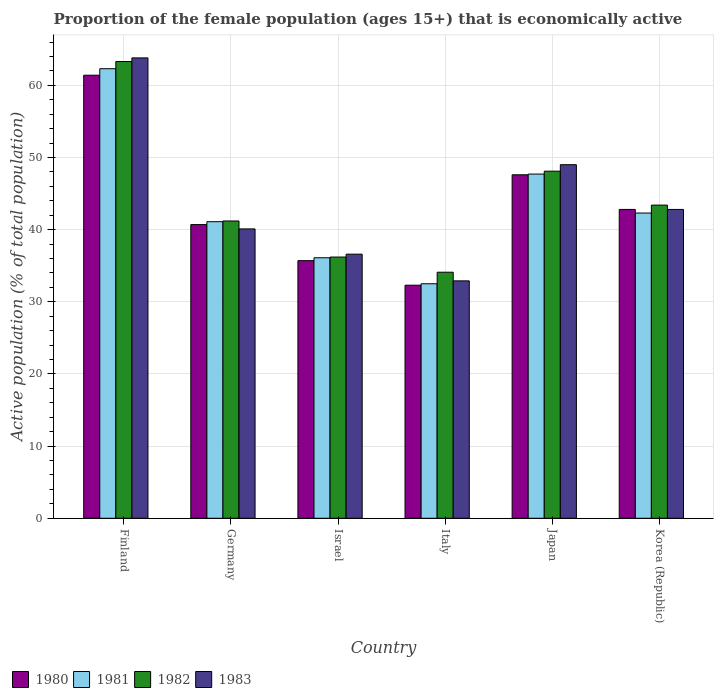Are the number of bars on each tick of the X-axis equal?
Offer a very short reply. Yes. How many bars are there on the 5th tick from the left?
Offer a very short reply. 4. What is the proportion of the female population that is economically active in 1981 in Korea (Republic)?
Keep it short and to the point. 42.3. Across all countries, what is the maximum proportion of the female population that is economically active in 1982?
Offer a terse response. 63.3. Across all countries, what is the minimum proportion of the female population that is economically active in 1983?
Your answer should be very brief. 32.9. In which country was the proportion of the female population that is economically active in 1982 minimum?
Offer a terse response. Italy. What is the total proportion of the female population that is economically active in 1982 in the graph?
Offer a very short reply. 266.3. What is the difference between the proportion of the female population that is economically active in 1980 in Finland and that in Italy?
Provide a succinct answer. 29.1. What is the difference between the proportion of the female population that is economically active in 1980 in Israel and the proportion of the female population that is economically active in 1981 in Finland?
Keep it short and to the point. -26.6. What is the average proportion of the female population that is economically active in 1981 per country?
Offer a terse response. 43.67. What is the difference between the proportion of the female population that is economically active of/in 1980 and proportion of the female population that is economically active of/in 1982 in Italy?
Offer a terse response. -1.8. What is the ratio of the proportion of the female population that is economically active in 1982 in Israel to that in Italy?
Give a very brief answer. 1.06. Is the difference between the proportion of the female population that is economically active in 1980 in Finland and Germany greater than the difference between the proportion of the female population that is economically active in 1982 in Finland and Germany?
Keep it short and to the point. No. What is the difference between the highest and the lowest proportion of the female population that is economically active in 1983?
Provide a succinct answer. 30.9. Is the sum of the proportion of the female population that is economically active in 1980 in Israel and Italy greater than the maximum proportion of the female population that is economically active in 1981 across all countries?
Provide a succinct answer. Yes. Is it the case that in every country, the sum of the proportion of the female population that is economically active in 1982 and proportion of the female population that is economically active in 1981 is greater than the sum of proportion of the female population that is economically active in 1983 and proportion of the female population that is economically active in 1980?
Your response must be concise. No. What does the 2nd bar from the left in Israel represents?
Your answer should be very brief. 1981. How many bars are there?
Your answer should be very brief. 24. Are all the bars in the graph horizontal?
Give a very brief answer. No. How many countries are there in the graph?
Provide a short and direct response. 6. What is the difference between two consecutive major ticks on the Y-axis?
Keep it short and to the point. 10. Does the graph contain any zero values?
Ensure brevity in your answer.  No. Where does the legend appear in the graph?
Your answer should be compact. Bottom left. What is the title of the graph?
Your answer should be compact. Proportion of the female population (ages 15+) that is economically active. What is the label or title of the X-axis?
Offer a very short reply. Country. What is the label or title of the Y-axis?
Ensure brevity in your answer.  Active population (% of total population). What is the Active population (% of total population) of 1980 in Finland?
Ensure brevity in your answer.  61.4. What is the Active population (% of total population) of 1981 in Finland?
Ensure brevity in your answer.  62.3. What is the Active population (% of total population) of 1982 in Finland?
Your answer should be compact. 63.3. What is the Active population (% of total population) of 1983 in Finland?
Give a very brief answer. 63.8. What is the Active population (% of total population) of 1980 in Germany?
Your response must be concise. 40.7. What is the Active population (% of total population) in 1981 in Germany?
Make the answer very short. 41.1. What is the Active population (% of total population) of 1982 in Germany?
Make the answer very short. 41.2. What is the Active population (% of total population) in 1983 in Germany?
Offer a terse response. 40.1. What is the Active population (% of total population) in 1980 in Israel?
Provide a succinct answer. 35.7. What is the Active population (% of total population) in 1981 in Israel?
Ensure brevity in your answer.  36.1. What is the Active population (% of total population) in 1982 in Israel?
Provide a succinct answer. 36.2. What is the Active population (% of total population) in 1983 in Israel?
Provide a short and direct response. 36.6. What is the Active population (% of total population) in 1980 in Italy?
Make the answer very short. 32.3. What is the Active population (% of total population) of 1981 in Italy?
Your answer should be compact. 32.5. What is the Active population (% of total population) of 1982 in Italy?
Ensure brevity in your answer.  34.1. What is the Active population (% of total population) of 1983 in Italy?
Keep it short and to the point. 32.9. What is the Active population (% of total population) of 1980 in Japan?
Your response must be concise. 47.6. What is the Active population (% of total population) of 1981 in Japan?
Provide a short and direct response. 47.7. What is the Active population (% of total population) in 1982 in Japan?
Offer a terse response. 48.1. What is the Active population (% of total population) in 1983 in Japan?
Keep it short and to the point. 49. What is the Active population (% of total population) of 1980 in Korea (Republic)?
Give a very brief answer. 42.8. What is the Active population (% of total population) of 1981 in Korea (Republic)?
Provide a short and direct response. 42.3. What is the Active population (% of total population) of 1982 in Korea (Republic)?
Your answer should be very brief. 43.4. What is the Active population (% of total population) in 1983 in Korea (Republic)?
Give a very brief answer. 42.8. Across all countries, what is the maximum Active population (% of total population) of 1980?
Provide a succinct answer. 61.4. Across all countries, what is the maximum Active population (% of total population) of 1981?
Make the answer very short. 62.3. Across all countries, what is the maximum Active population (% of total population) in 1982?
Your answer should be very brief. 63.3. Across all countries, what is the maximum Active population (% of total population) in 1983?
Offer a very short reply. 63.8. Across all countries, what is the minimum Active population (% of total population) of 1980?
Your answer should be compact. 32.3. Across all countries, what is the minimum Active population (% of total population) in 1981?
Your answer should be compact. 32.5. Across all countries, what is the minimum Active population (% of total population) in 1982?
Your answer should be compact. 34.1. Across all countries, what is the minimum Active population (% of total population) in 1983?
Provide a short and direct response. 32.9. What is the total Active population (% of total population) of 1980 in the graph?
Keep it short and to the point. 260.5. What is the total Active population (% of total population) of 1981 in the graph?
Your response must be concise. 262. What is the total Active population (% of total population) of 1982 in the graph?
Offer a very short reply. 266.3. What is the total Active population (% of total population) of 1983 in the graph?
Give a very brief answer. 265.2. What is the difference between the Active population (% of total population) in 1980 in Finland and that in Germany?
Offer a terse response. 20.7. What is the difference between the Active population (% of total population) in 1981 in Finland and that in Germany?
Offer a terse response. 21.2. What is the difference between the Active population (% of total population) of 1982 in Finland and that in Germany?
Your answer should be very brief. 22.1. What is the difference between the Active population (% of total population) in 1983 in Finland and that in Germany?
Offer a very short reply. 23.7. What is the difference between the Active population (% of total population) in 1980 in Finland and that in Israel?
Make the answer very short. 25.7. What is the difference between the Active population (% of total population) in 1981 in Finland and that in Israel?
Your answer should be compact. 26.2. What is the difference between the Active population (% of total population) in 1982 in Finland and that in Israel?
Make the answer very short. 27.1. What is the difference between the Active population (% of total population) of 1983 in Finland and that in Israel?
Your answer should be compact. 27.2. What is the difference between the Active population (% of total population) of 1980 in Finland and that in Italy?
Give a very brief answer. 29.1. What is the difference between the Active population (% of total population) of 1981 in Finland and that in Italy?
Ensure brevity in your answer.  29.8. What is the difference between the Active population (% of total population) of 1982 in Finland and that in Italy?
Ensure brevity in your answer.  29.2. What is the difference between the Active population (% of total population) in 1983 in Finland and that in Italy?
Keep it short and to the point. 30.9. What is the difference between the Active population (% of total population) of 1982 in Finland and that in Japan?
Your answer should be compact. 15.2. What is the difference between the Active population (% of total population) in 1983 in Finland and that in Japan?
Keep it short and to the point. 14.8. What is the difference between the Active population (% of total population) of 1980 in Finland and that in Korea (Republic)?
Give a very brief answer. 18.6. What is the difference between the Active population (% of total population) in 1982 in Germany and that in Italy?
Your answer should be compact. 7.1. What is the difference between the Active population (% of total population) in 1983 in Germany and that in Italy?
Your response must be concise. 7.2. What is the difference between the Active population (% of total population) in 1980 in Germany and that in Japan?
Your answer should be very brief. -6.9. What is the difference between the Active population (% of total population) in 1981 in Germany and that in Japan?
Keep it short and to the point. -6.6. What is the difference between the Active population (% of total population) of 1980 in Germany and that in Korea (Republic)?
Offer a very short reply. -2.1. What is the difference between the Active population (% of total population) in 1982 in Germany and that in Korea (Republic)?
Provide a succinct answer. -2.2. What is the difference between the Active population (% of total population) of 1983 in Germany and that in Korea (Republic)?
Give a very brief answer. -2.7. What is the difference between the Active population (% of total population) of 1980 in Israel and that in Italy?
Make the answer very short. 3.4. What is the difference between the Active population (% of total population) in 1981 in Israel and that in Italy?
Your response must be concise. 3.6. What is the difference between the Active population (% of total population) of 1981 in Israel and that in Japan?
Provide a short and direct response. -11.6. What is the difference between the Active population (% of total population) in 1983 in Israel and that in Japan?
Keep it short and to the point. -12.4. What is the difference between the Active population (% of total population) in 1980 in Italy and that in Japan?
Offer a terse response. -15.3. What is the difference between the Active population (% of total population) of 1981 in Italy and that in Japan?
Your answer should be very brief. -15.2. What is the difference between the Active population (% of total population) of 1982 in Italy and that in Japan?
Offer a terse response. -14. What is the difference between the Active population (% of total population) in 1983 in Italy and that in Japan?
Make the answer very short. -16.1. What is the difference between the Active population (% of total population) of 1983 in Italy and that in Korea (Republic)?
Your answer should be compact. -9.9. What is the difference between the Active population (% of total population) of 1980 in Japan and that in Korea (Republic)?
Make the answer very short. 4.8. What is the difference between the Active population (% of total population) in 1981 in Japan and that in Korea (Republic)?
Provide a short and direct response. 5.4. What is the difference between the Active population (% of total population) of 1980 in Finland and the Active population (% of total population) of 1981 in Germany?
Provide a short and direct response. 20.3. What is the difference between the Active population (% of total population) of 1980 in Finland and the Active population (% of total population) of 1982 in Germany?
Your answer should be very brief. 20.2. What is the difference between the Active population (% of total population) of 1980 in Finland and the Active population (% of total population) of 1983 in Germany?
Keep it short and to the point. 21.3. What is the difference between the Active population (% of total population) in 1981 in Finland and the Active population (% of total population) in 1982 in Germany?
Provide a short and direct response. 21.1. What is the difference between the Active population (% of total population) of 1981 in Finland and the Active population (% of total population) of 1983 in Germany?
Your answer should be compact. 22.2. What is the difference between the Active population (% of total population) of 1982 in Finland and the Active population (% of total population) of 1983 in Germany?
Your response must be concise. 23.2. What is the difference between the Active population (% of total population) in 1980 in Finland and the Active population (% of total population) in 1981 in Israel?
Ensure brevity in your answer.  25.3. What is the difference between the Active population (% of total population) of 1980 in Finland and the Active population (% of total population) of 1982 in Israel?
Ensure brevity in your answer.  25.2. What is the difference between the Active population (% of total population) of 1980 in Finland and the Active population (% of total population) of 1983 in Israel?
Keep it short and to the point. 24.8. What is the difference between the Active population (% of total population) in 1981 in Finland and the Active population (% of total population) in 1982 in Israel?
Make the answer very short. 26.1. What is the difference between the Active population (% of total population) of 1981 in Finland and the Active population (% of total population) of 1983 in Israel?
Give a very brief answer. 25.7. What is the difference between the Active population (% of total population) in 1982 in Finland and the Active population (% of total population) in 1983 in Israel?
Provide a succinct answer. 26.7. What is the difference between the Active population (% of total population) in 1980 in Finland and the Active population (% of total population) in 1981 in Italy?
Make the answer very short. 28.9. What is the difference between the Active population (% of total population) in 1980 in Finland and the Active population (% of total population) in 1982 in Italy?
Your response must be concise. 27.3. What is the difference between the Active population (% of total population) in 1981 in Finland and the Active population (% of total population) in 1982 in Italy?
Ensure brevity in your answer.  28.2. What is the difference between the Active population (% of total population) in 1981 in Finland and the Active population (% of total population) in 1983 in Italy?
Offer a terse response. 29.4. What is the difference between the Active population (% of total population) of 1982 in Finland and the Active population (% of total population) of 1983 in Italy?
Your answer should be compact. 30.4. What is the difference between the Active population (% of total population) of 1980 in Finland and the Active population (% of total population) of 1981 in Japan?
Ensure brevity in your answer.  13.7. What is the difference between the Active population (% of total population) of 1980 in Finland and the Active population (% of total population) of 1982 in Japan?
Your answer should be compact. 13.3. What is the difference between the Active population (% of total population) in 1982 in Finland and the Active population (% of total population) in 1983 in Japan?
Make the answer very short. 14.3. What is the difference between the Active population (% of total population) in 1980 in Finland and the Active population (% of total population) in 1983 in Korea (Republic)?
Ensure brevity in your answer.  18.6. What is the difference between the Active population (% of total population) in 1980 in Germany and the Active population (% of total population) in 1981 in Israel?
Your response must be concise. 4.6. What is the difference between the Active population (% of total population) of 1982 in Germany and the Active population (% of total population) of 1983 in Israel?
Your response must be concise. 4.6. What is the difference between the Active population (% of total population) in 1981 in Germany and the Active population (% of total population) in 1982 in Italy?
Give a very brief answer. 7. What is the difference between the Active population (% of total population) in 1982 in Germany and the Active population (% of total population) in 1983 in Italy?
Ensure brevity in your answer.  8.3. What is the difference between the Active population (% of total population) of 1980 in Germany and the Active population (% of total population) of 1982 in Japan?
Make the answer very short. -7.4. What is the difference between the Active population (% of total population) in 1980 in Germany and the Active population (% of total population) in 1983 in Japan?
Your response must be concise. -8.3. What is the difference between the Active population (% of total population) in 1981 in Germany and the Active population (% of total population) in 1982 in Japan?
Offer a terse response. -7. What is the difference between the Active population (% of total population) of 1981 in Germany and the Active population (% of total population) of 1983 in Japan?
Your answer should be compact. -7.9. What is the difference between the Active population (% of total population) in 1980 in Germany and the Active population (% of total population) in 1982 in Korea (Republic)?
Your answer should be compact. -2.7. What is the difference between the Active population (% of total population) of 1981 in Germany and the Active population (% of total population) of 1982 in Korea (Republic)?
Ensure brevity in your answer.  -2.3. What is the difference between the Active population (% of total population) of 1980 in Israel and the Active population (% of total population) of 1982 in Italy?
Keep it short and to the point. 1.6. What is the difference between the Active population (% of total population) of 1981 in Israel and the Active population (% of total population) of 1982 in Italy?
Your answer should be compact. 2. What is the difference between the Active population (% of total population) in 1981 in Israel and the Active population (% of total population) in 1983 in Italy?
Offer a terse response. 3.2. What is the difference between the Active population (% of total population) in 1982 in Israel and the Active population (% of total population) in 1983 in Italy?
Make the answer very short. 3.3. What is the difference between the Active population (% of total population) of 1980 in Israel and the Active population (% of total population) of 1981 in Japan?
Give a very brief answer. -12. What is the difference between the Active population (% of total population) of 1980 in Israel and the Active population (% of total population) of 1982 in Japan?
Your answer should be compact. -12.4. What is the difference between the Active population (% of total population) of 1980 in Israel and the Active population (% of total population) of 1983 in Japan?
Offer a very short reply. -13.3. What is the difference between the Active population (% of total population) of 1981 in Israel and the Active population (% of total population) of 1982 in Japan?
Offer a very short reply. -12. What is the difference between the Active population (% of total population) of 1980 in Israel and the Active population (% of total population) of 1983 in Korea (Republic)?
Give a very brief answer. -7.1. What is the difference between the Active population (% of total population) in 1981 in Israel and the Active population (% of total population) in 1983 in Korea (Republic)?
Provide a short and direct response. -6.7. What is the difference between the Active population (% of total population) of 1982 in Israel and the Active population (% of total population) of 1983 in Korea (Republic)?
Provide a short and direct response. -6.6. What is the difference between the Active population (% of total population) in 1980 in Italy and the Active population (% of total population) in 1981 in Japan?
Offer a terse response. -15.4. What is the difference between the Active population (% of total population) of 1980 in Italy and the Active population (% of total population) of 1982 in Japan?
Offer a terse response. -15.8. What is the difference between the Active population (% of total population) in 1980 in Italy and the Active population (% of total population) in 1983 in Japan?
Keep it short and to the point. -16.7. What is the difference between the Active population (% of total population) in 1981 in Italy and the Active population (% of total population) in 1982 in Japan?
Provide a short and direct response. -15.6. What is the difference between the Active population (% of total population) in 1981 in Italy and the Active population (% of total population) in 1983 in Japan?
Provide a short and direct response. -16.5. What is the difference between the Active population (% of total population) of 1982 in Italy and the Active population (% of total population) of 1983 in Japan?
Give a very brief answer. -14.9. What is the difference between the Active population (% of total population) in 1980 in Italy and the Active population (% of total population) in 1982 in Korea (Republic)?
Give a very brief answer. -11.1. What is the difference between the Active population (% of total population) of 1981 in Italy and the Active population (% of total population) of 1982 in Korea (Republic)?
Provide a succinct answer. -10.9. What is the difference between the Active population (% of total population) of 1981 in Italy and the Active population (% of total population) of 1983 in Korea (Republic)?
Your response must be concise. -10.3. What is the difference between the Active population (% of total population) of 1981 in Japan and the Active population (% of total population) of 1982 in Korea (Republic)?
Offer a terse response. 4.3. What is the difference between the Active population (% of total population) in 1982 in Japan and the Active population (% of total population) in 1983 in Korea (Republic)?
Offer a very short reply. 5.3. What is the average Active population (% of total population) of 1980 per country?
Provide a succinct answer. 43.42. What is the average Active population (% of total population) of 1981 per country?
Your answer should be very brief. 43.67. What is the average Active population (% of total population) in 1982 per country?
Make the answer very short. 44.38. What is the average Active population (% of total population) of 1983 per country?
Offer a terse response. 44.2. What is the difference between the Active population (% of total population) of 1980 and Active population (% of total population) of 1982 in Finland?
Your response must be concise. -1.9. What is the difference between the Active population (% of total population) in 1981 and Active population (% of total population) in 1982 in Finland?
Your answer should be compact. -1. What is the difference between the Active population (% of total population) in 1981 and Active population (% of total population) in 1983 in Finland?
Your answer should be very brief. -1.5. What is the difference between the Active population (% of total population) of 1980 and Active population (% of total population) of 1981 in Germany?
Provide a succinct answer. -0.4. What is the difference between the Active population (% of total population) in 1980 and Active population (% of total population) in 1983 in Germany?
Provide a succinct answer. 0.6. What is the difference between the Active population (% of total population) of 1981 and Active population (% of total population) of 1982 in Germany?
Make the answer very short. -0.1. What is the difference between the Active population (% of total population) of 1981 and Active population (% of total population) of 1983 in Germany?
Provide a short and direct response. 1. What is the difference between the Active population (% of total population) in 1982 and Active population (% of total population) in 1983 in Germany?
Give a very brief answer. 1.1. What is the difference between the Active population (% of total population) of 1980 and Active population (% of total population) of 1982 in Israel?
Offer a terse response. -0.5. What is the difference between the Active population (% of total population) in 1980 and Active population (% of total population) in 1983 in Israel?
Give a very brief answer. -0.9. What is the difference between the Active population (% of total population) of 1981 and Active population (% of total population) of 1983 in Israel?
Give a very brief answer. -0.5. What is the difference between the Active population (% of total population) of 1980 and Active population (% of total population) of 1982 in Italy?
Give a very brief answer. -1.8. What is the difference between the Active population (% of total population) of 1980 and Active population (% of total population) of 1983 in Italy?
Keep it short and to the point. -0.6. What is the difference between the Active population (% of total population) in 1981 and Active population (% of total population) in 1982 in Italy?
Provide a succinct answer. -1.6. What is the difference between the Active population (% of total population) of 1981 and Active population (% of total population) of 1983 in Italy?
Ensure brevity in your answer.  -0.4. What is the difference between the Active population (% of total population) of 1982 and Active population (% of total population) of 1983 in Italy?
Offer a terse response. 1.2. What is the difference between the Active population (% of total population) of 1980 and Active population (% of total population) of 1982 in Japan?
Ensure brevity in your answer.  -0.5. What is the difference between the Active population (% of total population) of 1980 and Active population (% of total population) of 1983 in Japan?
Offer a very short reply. -1.4. What is the difference between the Active population (% of total population) in 1981 and Active population (% of total population) in 1982 in Japan?
Your answer should be very brief. -0.4. What is the difference between the Active population (% of total population) of 1980 and Active population (% of total population) of 1983 in Korea (Republic)?
Provide a short and direct response. 0. What is the difference between the Active population (% of total population) of 1981 and Active population (% of total population) of 1982 in Korea (Republic)?
Your response must be concise. -1.1. What is the ratio of the Active population (% of total population) of 1980 in Finland to that in Germany?
Your answer should be very brief. 1.51. What is the ratio of the Active population (% of total population) of 1981 in Finland to that in Germany?
Make the answer very short. 1.52. What is the ratio of the Active population (% of total population) of 1982 in Finland to that in Germany?
Your response must be concise. 1.54. What is the ratio of the Active population (% of total population) in 1983 in Finland to that in Germany?
Make the answer very short. 1.59. What is the ratio of the Active population (% of total population) in 1980 in Finland to that in Israel?
Your response must be concise. 1.72. What is the ratio of the Active population (% of total population) of 1981 in Finland to that in Israel?
Offer a very short reply. 1.73. What is the ratio of the Active population (% of total population) of 1982 in Finland to that in Israel?
Offer a very short reply. 1.75. What is the ratio of the Active population (% of total population) of 1983 in Finland to that in Israel?
Provide a short and direct response. 1.74. What is the ratio of the Active population (% of total population) of 1980 in Finland to that in Italy?
Give a very brief answer. 1.9. What is the ratio of the Active population (% of total population) in 1981 in Finland to that in Italy?
Give a very brief answer. 1.92. What is the ratio of the Active population (% of total population) in 1982 in Finland to that in Italy?
Give a very brief answer. 1.86. What is the ratio of the Active population (% of total population) of 1983 in Finland to that in Italy?
Offer a very short reply. 1.94. What is the ratio of the Active population (% of total population) of 1980 in Finland to that in Japan?
Keep it short and to the point. 1.29. What is the ratio of the Active population (% of total population) in 1981 in Finland to that in Japan?
Ensure brevity in your answer.  1.31. What is the ratio of the Active population (% of total population) in 1982 in Finland to that in Japan?
Provide a succinct answer. 1.32. What is the ratio of the Active population (% of total population) in 1983 in Finland to that in Japan?
Provide a succinct answer. 1.3. What is the ratio of the Active population (% of total population) of 1980 in Finland to that in Korea (Republic)?
Your answer should be compact. 1.43. What is the ratio of the Active population (% of total population) of 1981 in Finland to that in Korea (Republic)?
Your answer should be very brief. 1.47. What is the ratio of the Active population (% of total population) in 1982 in Finland to that in Korea (Republic)?
Ensure brevity in your answer.  1.46. What is the ratio of the Active population (% of total population) of 1983 in Finland to that in Korea (Republic)?
Keep it short and to the point. 1.49. What is the ratio of the Active population (% of total population) of 1980 in Germany to that in Israel?
Offer a very short reply. 1.14. What is the ratio of the Active population (% of total population) of 1981 in Germany to that in Israel?
Your answer should be compact. 1.14. What is the ratio of the Active population (% of total population) in 1982 in Germany to that in Israel?
Ensure brevity in your answer.  1.14. What is the ratio of the Active population (% of total population) in 1983 in Germany to that in Israel?
Ensure brevity in your answer.  1.1. What is the ratio of the Active population (% of total population) of 1980 in Germany to that in Italy?
Ensure brevity in your answer.  1.26. What is the ratio of the Active population (% of total population) in 1981 in Germany to that in Italy?
Offer a very short reply. 1.26. What is the ratio of the Active population (% of total population) in 1982 in Germany to that in Italy?
Your response must be concise. 1.21. What is the ratio of the Active population (% of total population) of 1983 in Germany to that in Italy?
Ensure brevity in your answer.  1.22. What is the ratio of the Active population (% of total population) of 1980 in Germany to that in Japan?
Your response must be concise. 0.85. What is the ratio of the Active population (% of total population) in 1981 in Germany to that in Japan?
Give a very brief answer. 0.86. What is the ratio of the Active population (% of total population) in 1982 in Germany to that in Japan?
Keep it short and to the point. 0.86. What is the ratio of the Active population (% of total population) of 1983 in Germany to that in Japan?
Your answer should be compact. 0.82. What is the ratio of the Active population (% of total population) of 1980 in Germany to that in Korea (Republic)?
Provide a succinct answer. 0.95. What is the ratio of the Active population (% of total population) in 1981 in Germany to that in Korea (Republic)?
Your response must be concise. 0.97. What is the ratio of the Active population (% of total population) in 1982 in Germany to that in Korea (Republic)?
Offer a terse response. 0.95. What is the ratio of the Active population (% of total population) in 1983 in Germany to that in Korea (Republic)?
Ensure brevity in your answer.  0.94. What is the ratio of the Active population (% of total population) of 1980 in Israel to that in Italy?
Ensure brevity in your answer.  1.11. What is the ratio of the Active population (% of total population) in 1981 in Israel to that in Italy?
Give a very brief answer. 1.11. What is the ratio of the Active population (% of total population) in 1982 in Israel to that in Italy?
Provide a short and direct response. 1.06. What is the ratio of the Active population (% of total population) in 1983 in Israel to that in Italy?
Ensure brevity in your answer.  1.11. What is the ratio of the Active population (% of total population) of 1980 in Israel to that in Japan?
Ensure brevity in your answer.  0.75. What is the ratio of the Active population (% of total population) of 1981 in Israel to that in Japan?
Keep it short and to the point. 0.76. What is the ratio of the Active population (% of total population) in 1982 in Israel to that in Japan?
Provide a short and direct response. 0.75. What is the ratio of the Active population (% of total population) in 1983 in Israel to that in Japan?
Your answer should be compact. 0.75. What is the ratio of the Active population (% of total population) of 1980 in Israel to that in Korea (Republic)?
Offer a very short reply. 0.83. What is the ratio of the Active population (% of total population) of 1981 in Israel to that in Korea (Republic)?
Give a very brief answer. 0.85. What is the ratio of the Active population (% of total population) of 1982 in Israel to that in Korea (Republic)?
Provide a short and direct response. 0.83. What is the ratio of the Active population (% of total population) of 1983 in Israel to that in Korea (Republic)?
Make the answer very short. 0.86. What is the ratio of the Active population (% of total population) of 1980 in Italy to that in Japan?
Ensure brevity in your answer.  0.68. What is the ratio of the Active population (% of total population) in 1981 in Italy to that in Japan?
Your answer should be very brief. 0.68. What is the ratio of the Active population (% of total population) in 1982 in Italy to that in Japan?
Offer a terse response. 0.71. What is the ratio of the Active population (% of total population) in 1983 in Italy to that in Japan?
Provide a short and direct response. 0.67. What is the ratio of the Active population (% of total population) of 1980 in Italy to that in Korea (Republic)?
Your answer should be very brief. 0.75. What is the ratio of the Active population (% of total population) of 1981 in Italy to that in Korea (Republic)?
Provide a succinct answer. 0.77. What is the ratio of the Active population (% of total population) in 1982 in Italy to that in Korea (Republic)?
Make the answer very short. 0.79. What is the ratio of the Active population (% of total population) of 1983 in Italy to that in Korea (Republic)?
Ensure brevity in your answer.  0.77. What is the ratio of the Active population (% of total population) in 1980 in Japan to that in Korea (Republic)?
Offer a terse response. 1.11. What is the ratio of the Active population (% of total population) of 1981 in Japan to that in Korea (Republic)?
Ensure brevity in your answer.  1.13. What is the ratio of the Active population (% of total population) in 1982 in Japan to that in Korea (Republic)?
Your response must be concise. 1.11. What is the ratio of the Active population (% of total population) of 1983 in Japan to that in Korea (Republic)?
Your answer should be very brief. 1.14. What is the difference between the highest and the second highest Active population (% of total population) in 1982?
Give a very brief answer. 15.2. What is the difference between the highest and the second highest Active population (% of total population) of 1983?
Offer a very short reply. 14.8. What is the difference between the highest and the lowest Active population (% of total population) in 1980?
Keep it short and to the point. 29.1. What is the difference between the highest and the lowest Active population (% of total population) of 1981?
Make the answer very short. 29.8. What is the difference between the highest and the lowest Active population (% of total population) in 1982?
Make the answer very short. 29.2. What is the difference between the highest and the lowest Active population (% of total population) in 1983?
Make the answer very short. 30.9. 